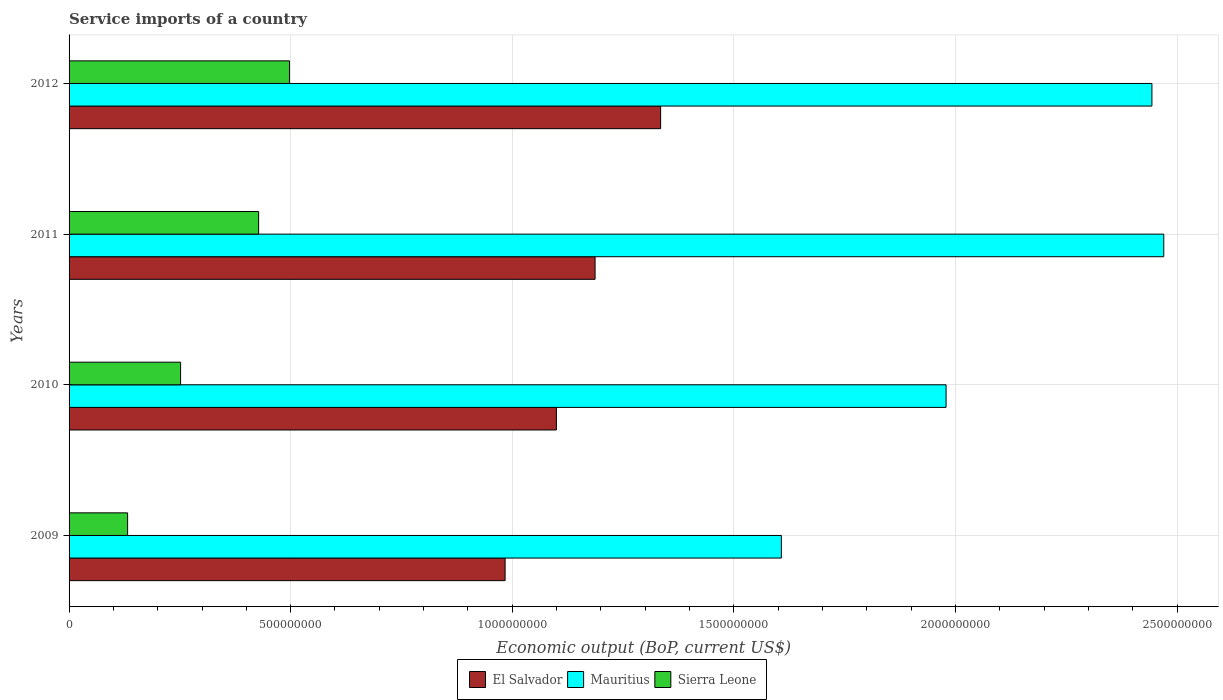What is the service imports in El Salvador in 2010?
Ensure brevity in your answer.  1.10e+09. Across all years, what is the maximum service imports in Sierra Leone?
Ensure brevity in your answer.  4.97e+08. Across all years, what is the minimum service imports in El Salvador?
Offer a terse response. 9.84e+08. In which year was the service imports in El Salvador maximum?
Make the answer very short. 2012. What is the total service imports in El Salvador in the graph?
Ensure brevity in your answer.  4.61e+09. What is the difference between the service imports in Sierra Leone in 2010 and that in 2012?
Provide a succinct answer. -2.46e+08. What is the difference between the service imports in El Salvador in 2010 and the service imports in Mauritius in 2012?
Your answer should be compact. -1.34e+09. What is the average service imports in El Salvador per year?
Make the answer very short. 1.15e+09. In the year 2011, what is the difference between the service imports in Sierra Leone and service imports in El Salvador?
Ensure brevity in your answer.  -7.59e+08. What is the ratio of the service imports in Sierra Leone in 2009 to that in 2010?
Make the answer very short. 0.52. What is the difference between the highest and the second highest service imports in El Salvador?
Your answer should be very brief. 1.48e+08. What is the difference between the highest and the lowest service imports in El Salvador?
Your response must be concise. 3.51e+08. In how many years, is the service imports in Sierra Leone greater than the average service imports in Sierra Leone taken over all years?
Your answer should be very brief. 2. What does the 1st bar from the top in 2012 represents?
Give a very brief answer. Sierra Leone. What does the 1st bar from the bottom in 2010 represents?
Your response must be concise. El Salvador. How many bars are there?
Your response must be concise. 12. How many years are there in the graph?
Your answer should be very brief. 4. What is the difference between two consecutive major ticks on the X-axis?
Your answer should be compact. 5.00e+08. Are the values on the major ticks of X-axis written in scientific E-notation?
Offer a very short reply. No. How many legend labels are there?
Provide a short and direct response. 3. What is the title of the graph?
Your answer should be very brief. Service imports of a country. Does "South Africa" appear as one of the legend labels in the graph?
Keep it short and to the point. No. What is the label or title of the X-axis?
Ensure brevity in your answer.  Economic output (BoP, current US$). What is the label or title of the Y-axis?
Your response must be concise. Years. What is the Economic output (BoP, current US$) in El Salvador in 2009?
Offer a terse response. 9.84e+08. What is the Economic output (BoP, current US$) in Mauritius in 2009?
Keep it short and to the point. 1.61e+09. What is the Economic output (BoP, current US$) in Sierra Leone in 2009?
Your response must be concise. 1.32e+08. What is the Economic output (BoP, current US$) of El Salvador in 2010?
Provide a succinct answer. 1.10e+09. What is the Economic output (BoP, current US$) of Mauritius in 2010?
Ensure brevity in your answer.  1.98e+09. What is the Economic output (BoP, current US$) of Sierra Leone in 2010?
Provide a short and direct response. 2.52e+08. What is the Economic output (BoP, current US$) in El Salvador in 2011?
Your answer should be very brief. 1.19e+09. What is the Economic output (BoP, current US$) of Mauritius in 2011?
Your response must be concise. 2.47e+09. What is the Economic output (BoP, current US$) of Sierra Leone in 2011?
Keep it short and to the point. 4.28e+08. What is the Economic output (BoP, current US$) of El Salvador in 2012?
Provide a short and direct response. 1.33e+09. What is the Economic output (BoP, current US$) of Mauritius in 2012?
Offer a terse response. 2.44e+09. What is the Economic output (BoP, current US$) of Sierra Leone in 2012?
Make the answer very short. 4.97e+08. Across all years, what is the maximum Economic output (BoP, current US$) of El Salvador?
Offer a terse response. 1.33e+09. Across all years, what is the maximum Economic output (BoP, current US$) of Mauritius?
Provide a short and direct response. 2.47e+09. Across all years, what is the maximum Economic output (BoP, current US$) in Sierra Leone?
Give a very brief answer. 4.97e+08. Across all years, what is the minimum Economic output (BoP, current US$) of El Salvador?
Provide a succinct answer. 9.84e+08. Across all years, what is the minimum Economic output (BoP, current US$) in Mauritius?
Offer a very short reply. 1.61e+09. Across all years, what is the minimum Economic output (BoP, current US$) of Sierra Leone?
Keep it short and to the point. 1.32e+08. What is the total Economic output (BoP, current US$) of El Salvador in the graph?
Keep it short and to the point. 4.61e+09. What is the total Economic output (BoP, current US$) of Mauritius in the graph?
Provide a short and direct response. 8.50e+09. What is the total Economic output (BoP, current US$) of Sierra Leone in the graph?
Provide a succinct answer. 1.31e+09. What is the difference between the Economic output (BoP, current US$) in El Salvador in 2009 and that in 2010?
Your answer should be very brief. -1.16e+08. What is the difference between the Economic output (BoP, current US$) of Mauritius in 2009 and that in 2010?
Keep it short and to the point. -3.72e+08. What is the difference between the Economic output (BoP, current US$) of Sierra Leone in 2009 and that in 2010?
Keep it short and to the point. -1.20e+08. What is the difference between the Economic output (BoP, current US$) of El Salvador in 2009 and that in 2011?
Give a very brief answer. -2.03e+08. What is the difference between the Economic output (BoP, current US$) in Mauritius in 2009 and that in 2011?
Your response must be concise. -8.63e+08. What is the difference between the Economic output (BoP, current US$) in Sierra Leone in 2009 and that in 2011?
Provide a succinct answer. -2.96e+08. What is the difference between the Economic output (BoP, current US$) of El Salvador in 2009 and that in 2012?
Your answer should be very brief. -3.51e+08. What is the difference between the Economic output (BoP, current US$) in Mauritius in 2009 and that in 2012?
Give a very brief answer. -8.36e+08. What is the difference between the Economic output (BoP, current US$) in Sierra Leone in 2009 and that in 2012?
Offer a terse response. -3.65e+08. What is the difference between the Economic output (BoP, current US$) in El Salvador in 2010 and that in 2011?
Provide a short and direct response. -8.72e+07. What is the difference between the Economic output (BoP, current US$) of Mauritius in 2010 and that in 2011?
Keep it short and to the point. -4.91e+08. What is the difference between the Economic output (BoP, current US$) in Sierra Leone in 2010 and that in 2011?
Offer a terse response. -1.76e+08. What is the difference between the Economic output (BoP, current US$) in El Salvador in 2010 and that in 2012?
Make the answer very short. -2.35e+08. What is the difference between the Economic output (BoP, current US$) in Mauritius in 2010 and that in 2012?
Your answer should be very brief. -4.65e+08. What is the difference between the Economic output (BoP, current US$) in Sierra Leone in 2010 and that in 2012?
Provide a short and direct response. -2.46e+08. What is the difference between the Economic output (BoP, current US$) of El Salvador in 2011 and that in 2012?
Give a very brief answer. -1.48e+08. What is the difference between the Economic output (BoP, current US$) in Mauritius in 2011 and that in 2012?
Ensure brevity in your answer.  2.67e+07. What is the difference between the Economic output (BoP, current US$) of Sierra Leone in 2011 and that in 2012?
Ensure brevity in your answer.  -6.97e+07. What is the difference between the Economic output (BoP, current US$) in El Salvador in 2009 and the Economic output (BoP, current US$) in Mauritius in 2010?
Ensure brevity in your answer.  -9.95e+08. What is the difference between the Economic output (BoP, current US$) of El Salvador in 2009 and the Economic output (BoP, current US$) of Sierra Leone in 2010?
Provide a short and direct response. 7.32e+08. What is the difference between the Economic output (BoP, current US$) in Mauritius in 2009 and the Economic output (BoP, current US$) in Sierra Leone in 2010?
Your answer should be very brief. 1.36e+09. What is the difference between the Economic output (BoP, current US$) in El Salvador in 2009 and the Economic output (BoP, current US$) in Mauritius in 2011?
Offer a very short reply. -1.49e+09. What is the difference between the Economic output (BoP, current US$) in El Salvador in 2009 and the Economic output (BoP, current US$) in Sierra Leone in 2011?
Your response must be concise. 5.56e+08. What is the difference between the Economic output (BoP, current US$) of Mauritius in 2009 and the Economic output (BoP, current US$) of Sierra Leone in 2011?
Give a very brief answer. 1.18e+09. What is the difference between the Economic output (BoP, current US$) in El Salvador in 2009 and the Economic output (BoP, current US$) in Mauritius in 2012?
Keep it short and to the point. -1.46e+09. What is the difference between the Economic output (BoP, current US$) of El Salvador in 2009 and the Economic output (BoP, current US$) of Sierra Leone in 2012?
Provide a succinct answer. 4.87e+08. What is the difference between the Economic output (BoP, current US$) of Mauritius in 2009 and the Economic output (BoP, current US$) of Sierra Leone in 2012?
Your response must be concise. 1.11e+09. What is the difference between the Economic output (BoP, current US$) in El Salvador in 2010 and the Economic output (BoP, current US$) in Mauritius in 2011?
Your answer should be compact. -1.37e+09. What is the difference between the Economic output (BoP, current US$) in El Salvador in 2010 and the Economic output (BoP, current US$) in Sierra Leone in 2011?
Provide a succinct answer. 6.72e+08. What is the difference between the Economic output (BoP, current US$) of Mauritius in 2010 and the Economic output (BoP, current US$) of Sierra Leone in 2011?
Your answer should be very brief. 1.55e+09. What is the difference between the Economic output (BoP, current US$) of El Salvador in 2010 and the Economic output (BoP, current US$) of Mauritius in 2012?
Provide a short and direct response. -1.34e+09. What is the difference between the Economic output (BoP, current US$) in El Salvador in 2010 and the Economic output (BoP, current US$) in Sierra Leone in 2012?
Keep it short and to the point. 6.02e+08. What is the difference between the Economic output (BoP, current US$) of Mauritius in 2010 and the Economic output (BoP, current US$) of Sierra Leone in 2012?
Keep it short and to the point. 1.48e+09. What is the difference between the Economic output (BoP, current US$) in El Salvador in 2011 and the Economic output (BoP, current US$) in Mauritius in 2012?
Provide a succinct answer. -1.26e+09. What is the difference between the Economic output (BoP, current US$) of El Salvador in 2011 and the Economic output (BoP, current US$) of Sierra Leone in 2012?
Provide a short and direct response. 6.90e+08. What is the difference between the Economic output (BoP, current US$) of Mauritius in 2011 and the Economic output (BoP, current US$) of Sierra Leone in 2012?
Your answer should be very brief. 1.97e+09. What is the average Economic output (BoP, current US$) in El Salvador per year?
Ensure brevity in your answer.  1.15e+09. What is the average Economic output (BoP, current US$) in Mauritius per year?
Offer a terse response. 2.12e+09. What is the average Economic output (BoP, current US$) in Sierra Leone per year?
Offer a very short reply. 3.27e+08. In the year 2009, what is the difference between the Economic output (BoP, current US$) of El Salvador and Economic output (BoP, current US$) of Mauritius?
Ensure brevity in your answer.  -6.23e+08. In the year 2009, what is the difference between the Economic output (BoP, current US$) of El Salvador and Economic output (BoP, current US$) of Sierra Leone?
Your answer should be compact. 8.52e+08. In the year 2009, what is the difference between the Economic output (BoP, current US$) in Mauritius and Economic output (BoP, current US$) in Sierra Leone?
Your answer should be compact. 1.48e+09. In the year 2010, what is the difference between the Economic output (BoP, current US$) of El Salvador and Economic output (BoP, current US$) of Mauritius?
Offer a terse response. -8.79e+08. In the year 2010, what is the difference between the Economic output (BoP, current US$) of El Salvador and Economic output (BoP, current US$) of Sierra Leone?
Provide a succinct answer. 8.48e+08. In the year 2010, what is the difference between the Economic output (BoP, current US$) of Mauritius and Economic output (BoP, current US$) of Sierra Leone?
Make the answer very short. 1.73e+09. In the year 2011, what is the difference between the Economic output (BoP, current US$) of El Salvador and Economic output (BoP, current US$) of Mauritius?
Ensure brevity in your answer.  -1.28e+09. In the year 2011, what is the difference between the Economic output (BoP, current US$) of El Salvador and Economic output (BoP, current US$) of Sierra Leone?
Make the answer very short. 7.59e+08. In the year 2011, what is the difference between the Economic output (BoP, current US$) in Mauritius and Economic output (BoP, current US$) in Sierra Leone?
Ensure brevity in your answer.  2.04e+09. In the year 2012, what is the difference between the Economic output (BoP, current US$) in El Salvador and Economic output (BoP, current US$) in Mauritius?
Your answer should be compact. -1.11e+09. In the year 2012, what is the difference between the Economic output (BoP, current US$) of El Salvador and Economic output (BoP, current US$) of Sierra Leone?
Provide a short and direct response. 8.37e+08. In the year 2012, what is the difference between the Economic output (BoP, current US$) of Mauritius and Economic output (BoP, current US$) of Sierra Leone?
Your answer should be very brief. 1.95e+09. What is the ratio of the Economic output (BoP, current US$) of El Salvador in 2009 to that in 2010?
Keep it short and to the point. 0.89. What is the ratio of the Economic output (BoP, current US$) in Mauritius in 2009 to that in 2010?
Provide a short and direct response. 0.81. What is the ratio of the Economic output (BoP, current US$) in Sierra Leone in 2009 to that in 2010?
Your answer should be compact. 0.53. What is the ratio of the Economic output (BoP, current US$) in El Salvador in 2009 to that in 2011?
Provide a succinct answer. 0.83. What is the ratio of the Economic output (BoP, current US$) of Mauritius in 2009 to that in 2011?
Offer a very short reply. 0.65. What is the ratio of the Economic output (BoP, current US$) of Sierra Leone in 2009 to that in 2011?
Provide a succinct answer. 0.31. What is the ratio of the Economic output (BoP, current US$) in El Salvador in 2009 to that in 2012?
Give a very brief answer. 0.74. What is the ratio of the Economic output (BoP, current US$) of Mauritius in 2009 to that in 2012?
Your answer should be very brief. 0.66. What is the ratio of the Economic output (BoP, current US$) of Sierra Leone in 2009 to that in 2012?
Your response must be concise. 0.27. What is the ratio of the Economic output (BoP, current US$) in El Salvador in 2010 to that in 2011?
Offer a very short reply. 0.93. What is the ratio of the Economic output (BoP, current US$) of Mauritius in 2010 to that in 2011?
Your response must be concise. 0.8. What is the ratio of the Economic output (BoP, current US$) in Sierra Leone in 2010 to that in 2011?
Your answer should be very brief. 0.59. What is the ratio of the Economic output (BoP, current US$) in El Salvador in 2010 to that in 2012?
Give a very brief answer. 0.82. What is the ratio of the Economic output (BoP, current US$) in Mauritius in 2010 to that in 2012?
Offer a terse response. 0.81. What is the ratio of the Economic output (BoP, current US$) of Sierra Leone in 2010 to that in 2012?
Your response must be concise. 0.51. What is the ratio of the Economic output (BoP, current US$) in El Salvador in 2011 to that in 2012?
Give a very brief answer. 0.89. What is the ratio of the Economic output (BoP, current US$) of Mauritius in 2011 to that in 2012?
Keep it short and to the point. 1.01. What is the ratio of the Economic output (BoP, current US$) of Sierra Leone in 2011 to that in 2012?
Offer a terse response. 0.86. What is the difference between the highest and the second highest Economic output (BoP, current US$) in El Salvador?
Offer a very short reply. 1.48e+08. What is the difference between the highest and the second highest Economic output (BoP, current US$) in Mauritius?
Provide a succinct answer. 2.67e+07. What is the difference between the highest and the second highest Economic output (BoP, current US$) in Sierra Leone?
Ensure brevity in your answer.  6.97e+07. What is the difference between the highest and the lowest Economic output (BoP, current US$) of El Salvador?
Offer a very short reply. 3.51e+08. What is the difference between the highest and the lowest Economic output (BoP, current US$) in Mauritius?
Ensure brevity in your answer.  8.63e+08. What is the difference between the highest and the lowest Economic output (BoP, current US$) in Sierra Leone?
Give a very brief answer. 3.65e+08. 